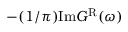Convert formula to latex. <formula><loc_0><loc_0><loc_500><loc_500>- ( 1 / \pi ) I m G ^ { R } ( \omega )</formula> 